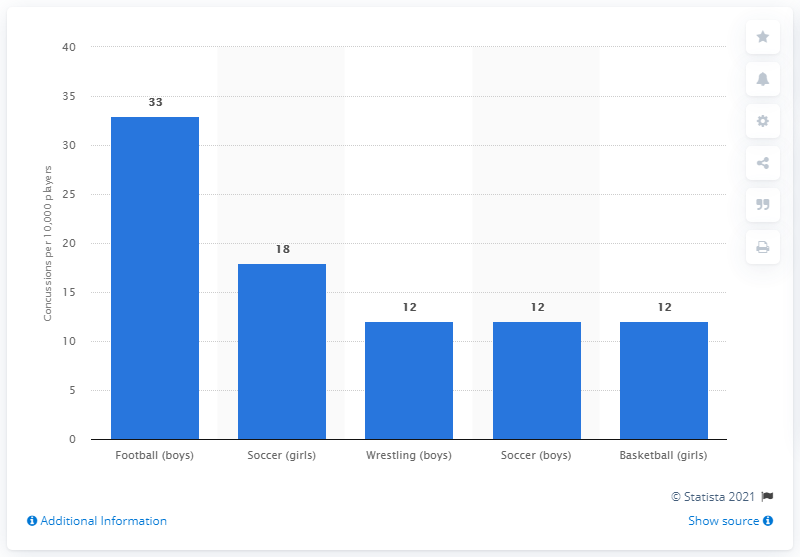Give some essential details in this illustration. During the 2013-2014 school year, a total of 12 concussions occurred per 10,000 high school players. 